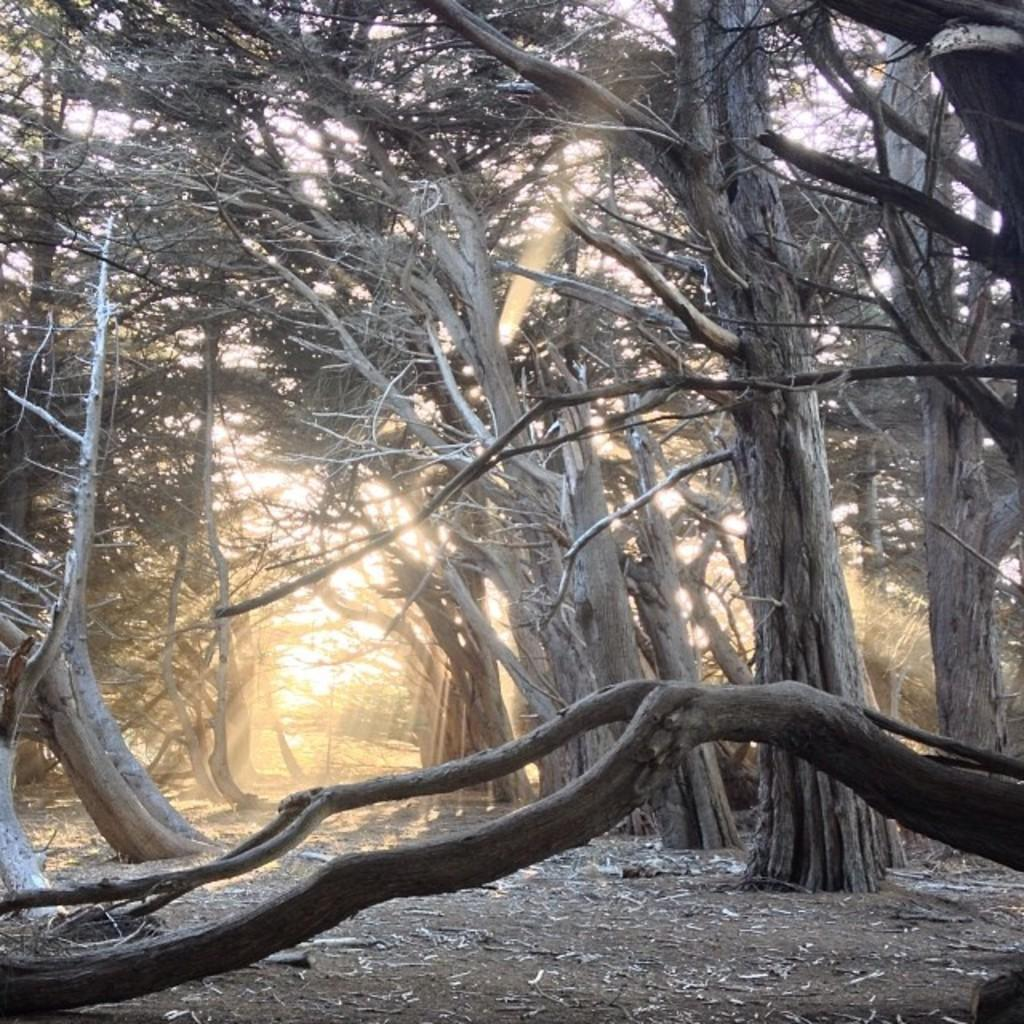What type of vegetation can be seen in the image? There are trees in the image. What is on the ground beneath the trees? Dry leaves are present on the ground. What can be seen in the background of the image? The background of the image includes sunlight. Where is the nest located in the image? There is no nest present in the image. What type of shock can be seen in the image? There is no shock present in the image. 